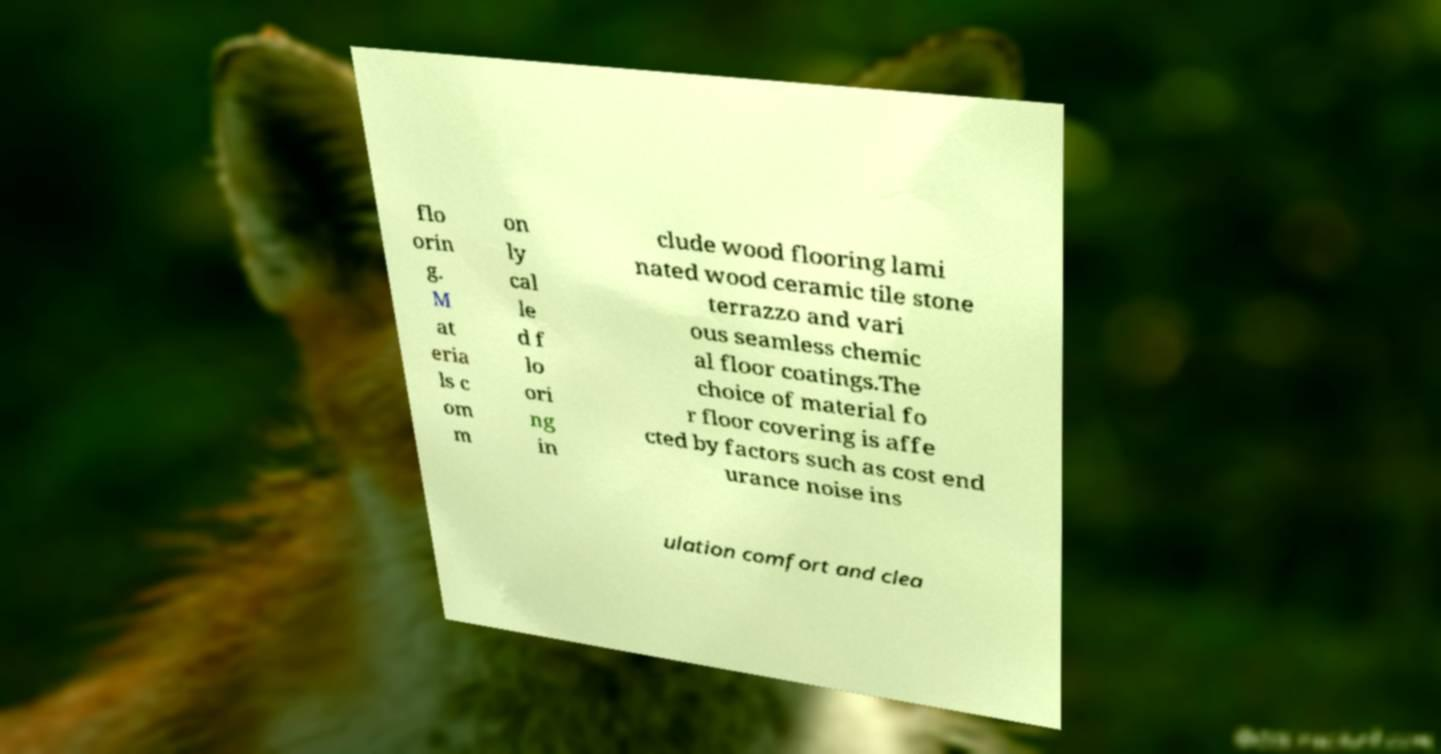I need the written content from this picture converted into text. Can you do that? flo orin g. M at eria ls c om m on ly cal le d f lo ori ng in clude wood flooring lami nated wood ceramic tile stone terrazzo and vari ous seamless chemic al floor coatings.The choice of material fo r floor covering is affe cted by factors such as cost end urance noise ins ulation comfort and clea 